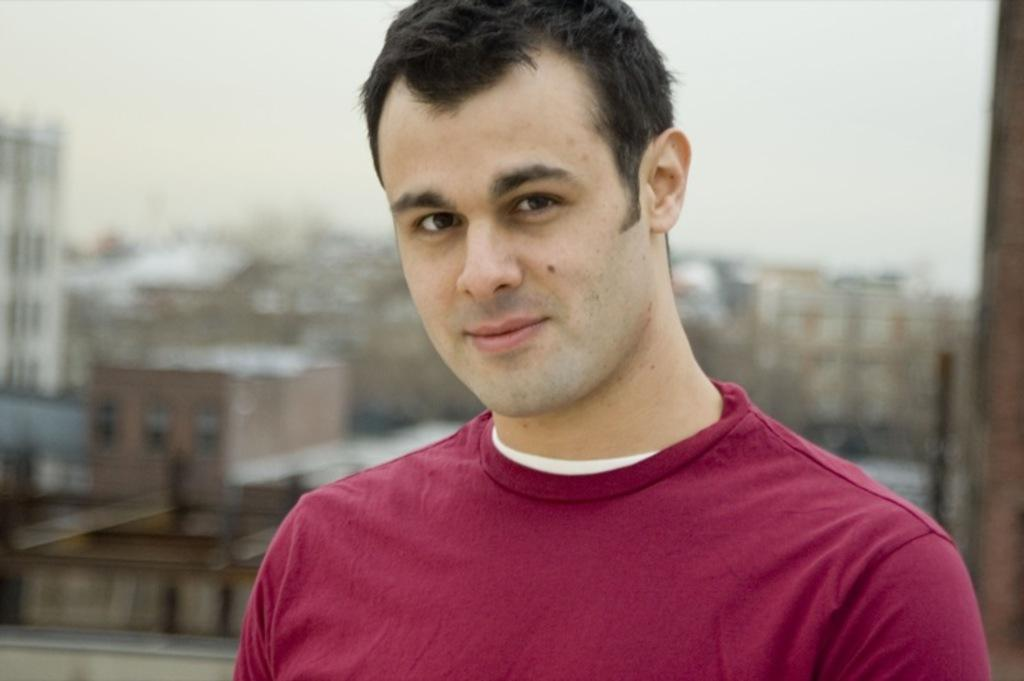Who is present in the image? There is a man in the image. What is the man doing in the image? The man is smiling in the image. What can be seen in the background of the image? There are trees visible in the background of the image. What type of fruit is hanging from the man's collar in the image? There is no fruit hanging from the man's collar in the image, nor is there a collar visible. 